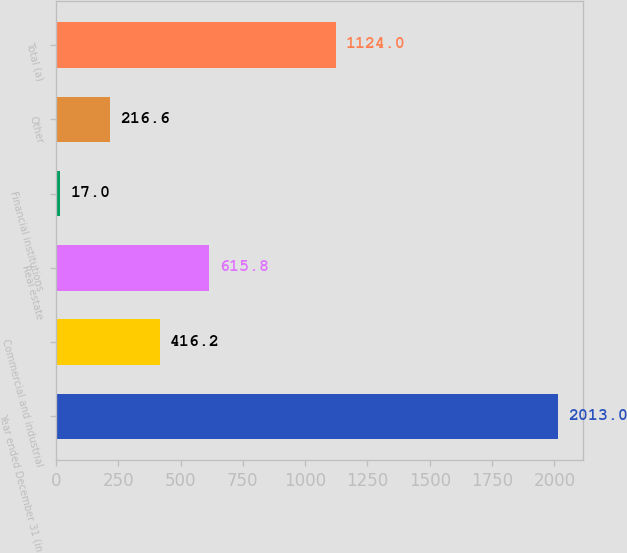<chart> <loc_0><loc_0><loc_500><loc_500><bar_chart><fcel>Year ended December 31 (in<fcel>Commercial and industrial<fcel>Real estate<fcel>Financial institutions<fcel>Other<fcel>Total (a)<nl><fcel>2013<fcel>416.2<fcel>615.8<fcel>17<fcel>216.6<fcel>1124<nl></chart> 